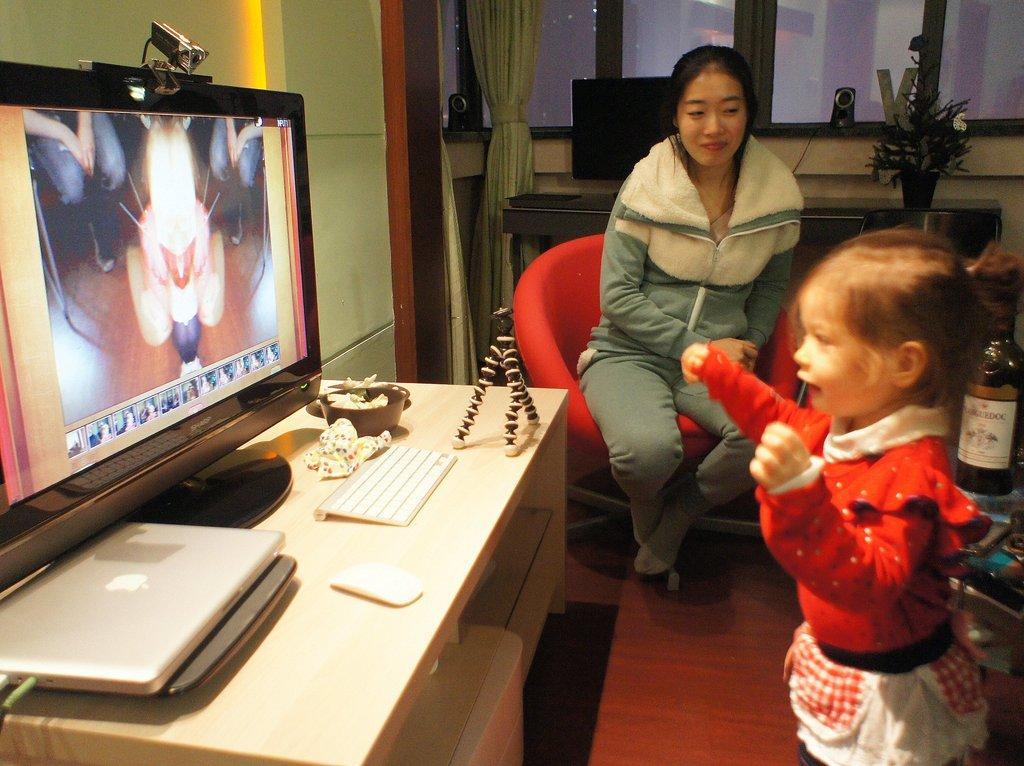Could you give a brief overview of what you see in this image? 2 people are present in a room. in the front a person is standing in front of a computer. at the back a person is sitting on the chair. in front of the computer there is a laptop,mouse. back of the room there are windows and curtains. 